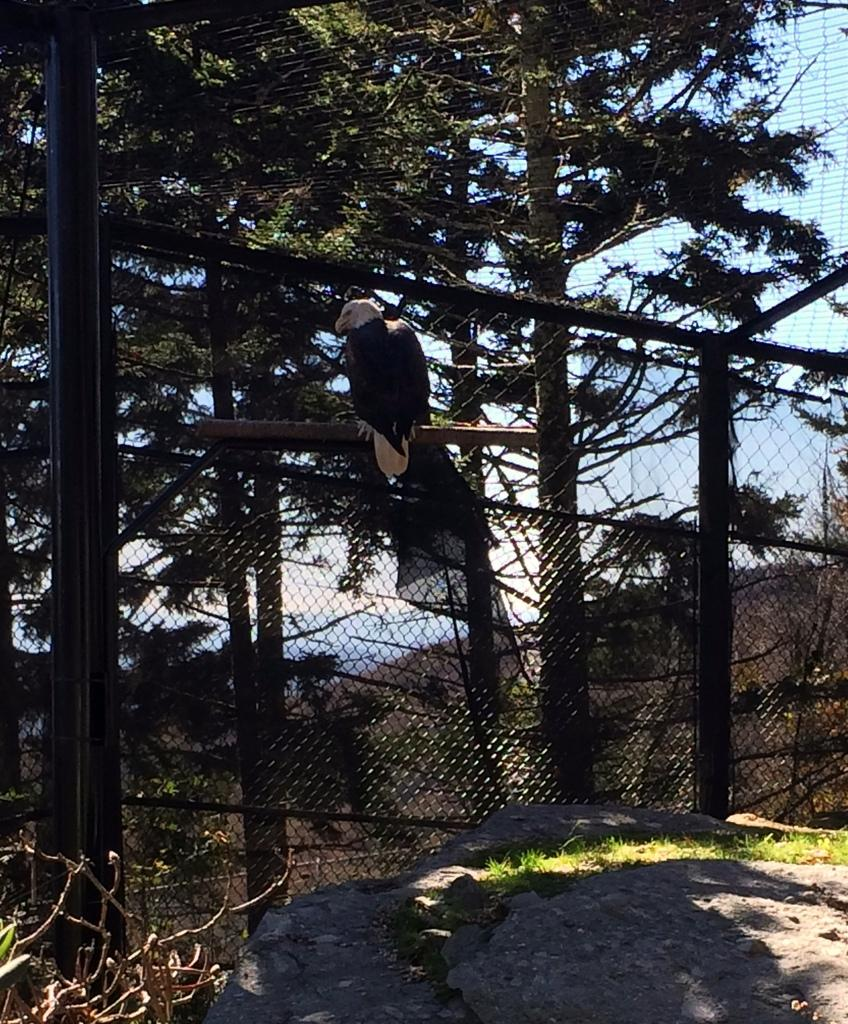What type of bird is in the image? There is a vulture in the image. Where is the vulture located? The vulture is standing on a fence. What is the terrain like where the fence is located? The fence is on rocky land. What can be seen in the distance in the image? There are trees visible in the background of the image. How many passengers are on the property in the image? There is no reference to passengers or property in the image; it features a vulture standing on a fence in a rocky landscape with trees in the background. 